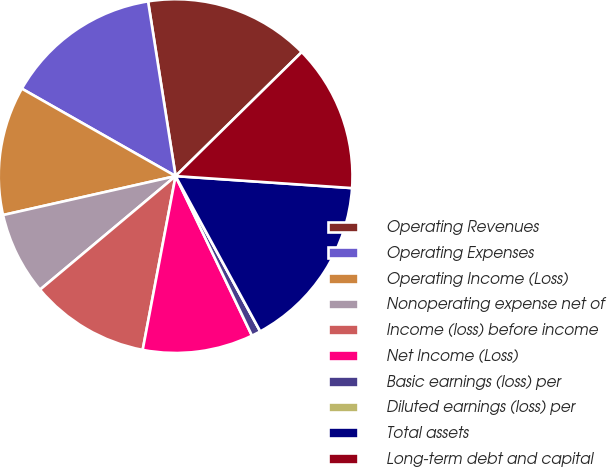<chart> <loc_0><loc_0><loc_500><loc_500><pie_chart><fcel>Operating Revenues<fcel>Operating Expenses<fcel>Operating Income (Loss)<fcel>Nonoperating expense net of<fcel>Income (loss) before income<fcel>Net Income (Loss)<fcel>Basic earnings (loss) per<fcel>Diluted earnings (loss) per<fcel>Total assets<fcel>Long-term debt and capital<nl><fcel>15.12%<fcel>14.28%<fcel>11.76%<fcel>7.56%<fcel>10.92%<fcel>10.08%<fcel>0.84%<fcel>0.0%<fcel>15.97%<fcel>13.44%<nl></chart> 